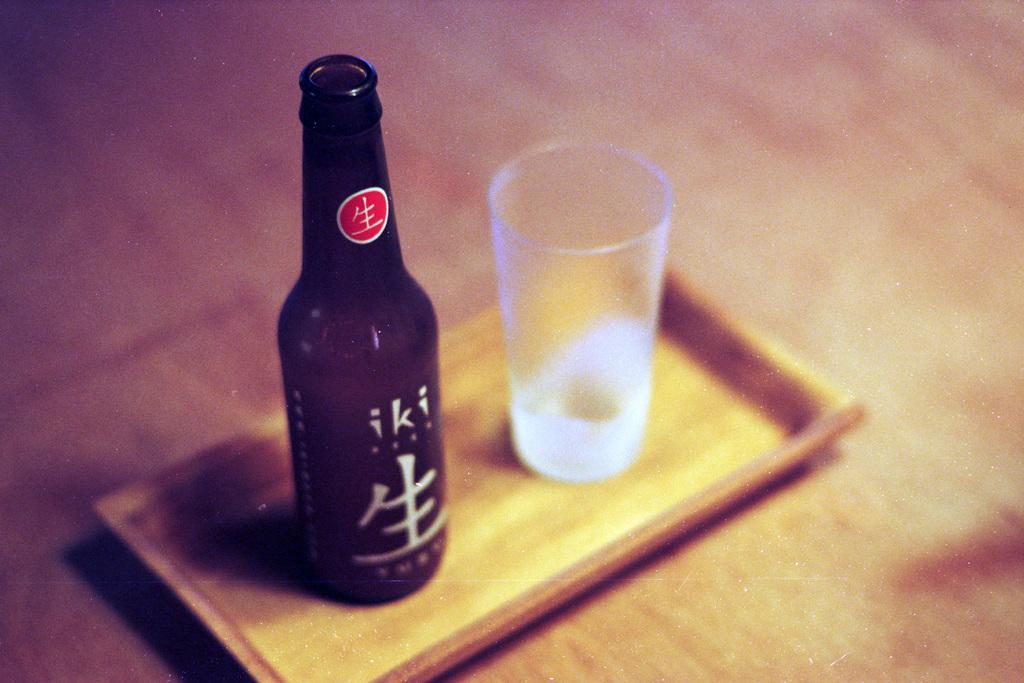Please provide a concise description of this image. In this image, we can see a wine bottle and a glass kept in a tray. 